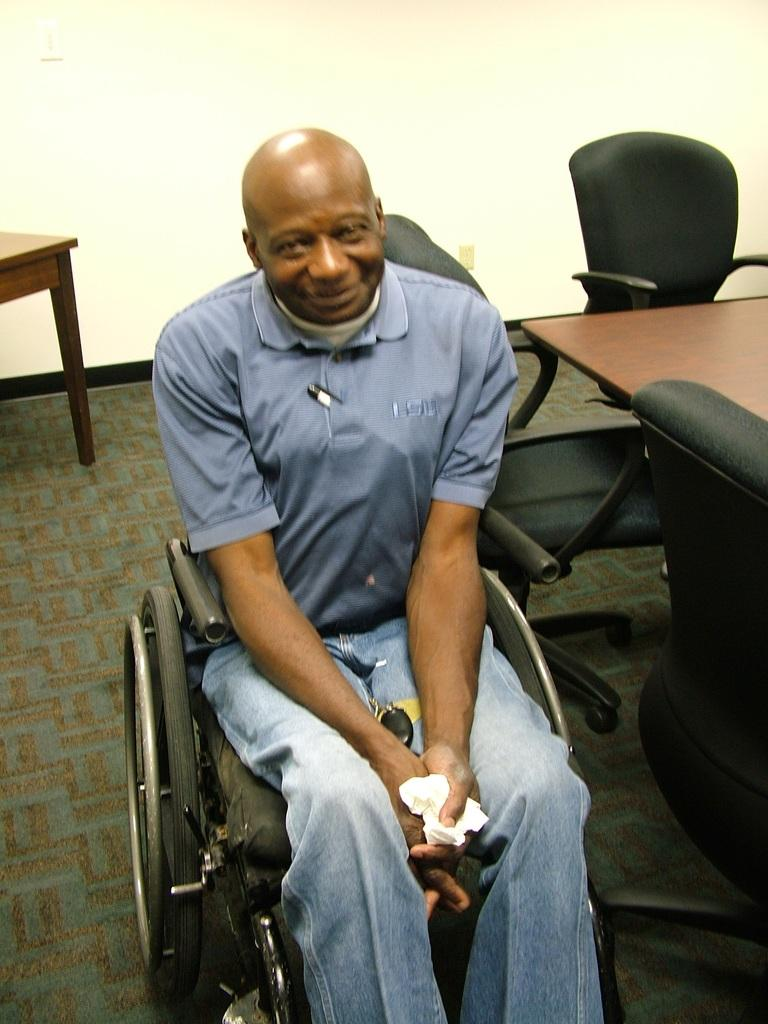What is the man in the image doing? The man is sitting on a wheelchair in the image. What is located behind the man? There is a table behind the man in the image. What can be seen in the background of the image? There are multiple chairs and a wall in the background of the image. How many tubs of paint are visible on the wall in the image? There are no tubs of paint visible on the wall in the image. 